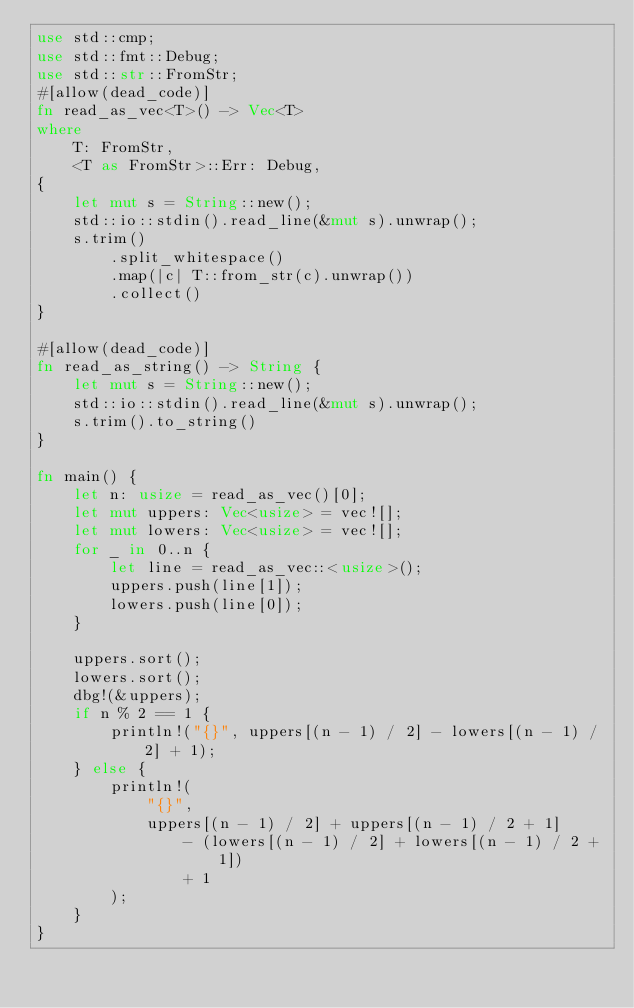<code> <loc_0><loc_0><loc_500><loc_500><_Rust_>use std::cmp;
use std::fmt::Debug;
use std::str::FromStr;
#[allow(dead_code)]
fn read_as_vec<T>() -> Vec<T>
where
    T: FromStr,
    <T as FromStr>::Err: Debug,
{
    let mut s = String::new();
    std::io::stdin().read_line(&mut s).unwrap();
    s.trim()
        .split_whitespace()
        .map(|c| T::from_str(c).unwrap())
        .collect()
}

#[allow(dead_code)]
fn read_as_string() -> String {
    let mut s = String::new();
    std::io::stdin().read_line(&mut s).unwrap();
    s.trim().to_string()
}

fn main() {
    let n: usize = read_as_vec()[0];
    let mut uppers: Vec<usize> = vec![];
    let mut lowers: Vec<usize> = vec![];
    for _ in 0..n {
        let line = read_as_vec::<usize>();
        uppers.push(line[1]);
        lowers.push(line[0]);
    }

    uppers.sort();
    lowers.sort();
    dbg!(&uppers);
    if n % 2 == 1 {
        println!("{}", uppers[(n - 1) / 2] - lowers[(n - 1) / 2] + 1);
    } else {
        println!(
            "{}",
            uppers[(n - 1) / 2] + uppers[(n - 1) / 2 + 1]
                - (lowers[(n - 1) / 2] + lowers[(n - 1) / 2 + 1])
                + 1
        );
    }
}
</code> 